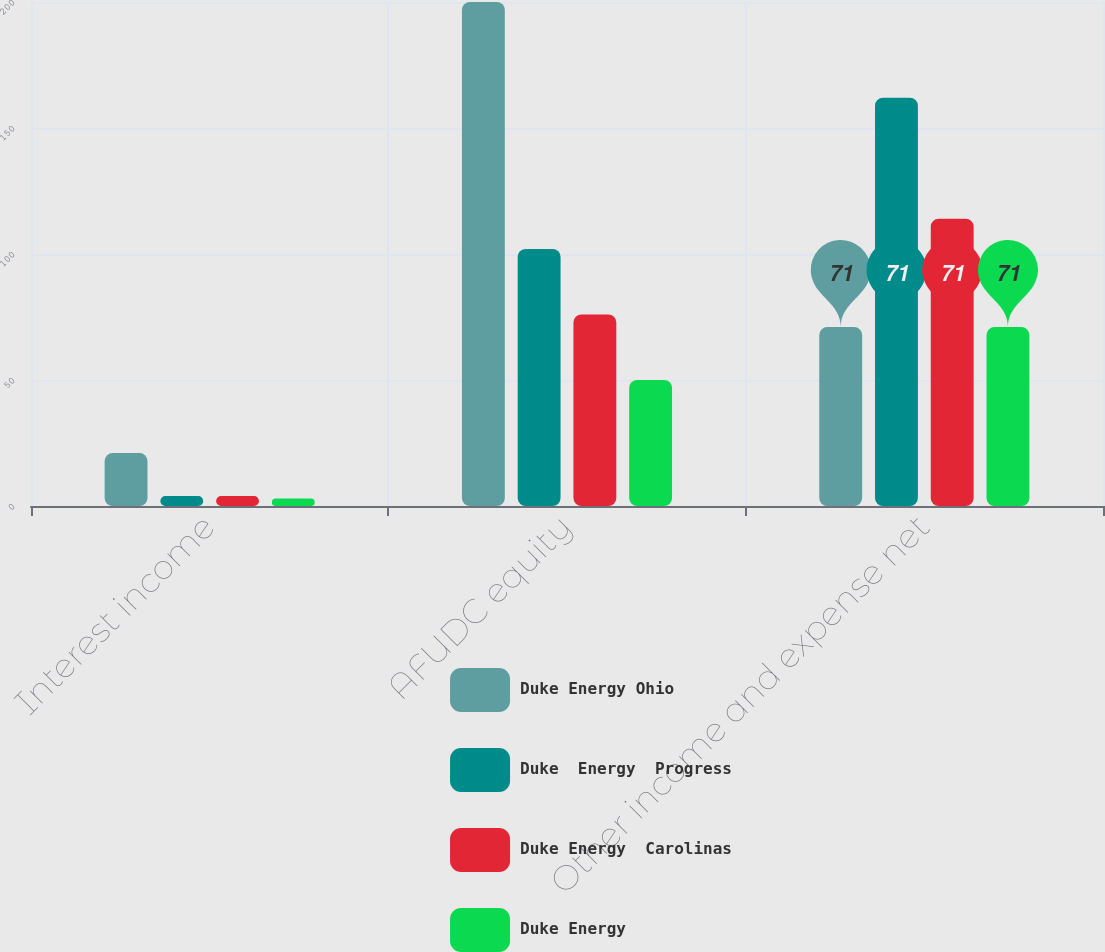<chart> <loc_0><loc_0><loc_500><loc_500><stacked_bar_chart><ecel><fcel>Interest income<fcel>AFUDC equity<fcel>Other income and expense net<nl><fcel>Duke Energy Ohio<fcel>21<fcel>200<fcel>71<nl><fcel>Duke  Energy  Progress<fcel>4<fcel>102<fcel>162<nl><fcel>Duke Energy  Carolinas<fcel>4<fcel>76<fcel>114<nl><fcel>Duke Energy<fcel>3<fcel>50<fcel>71<nl></chart> 